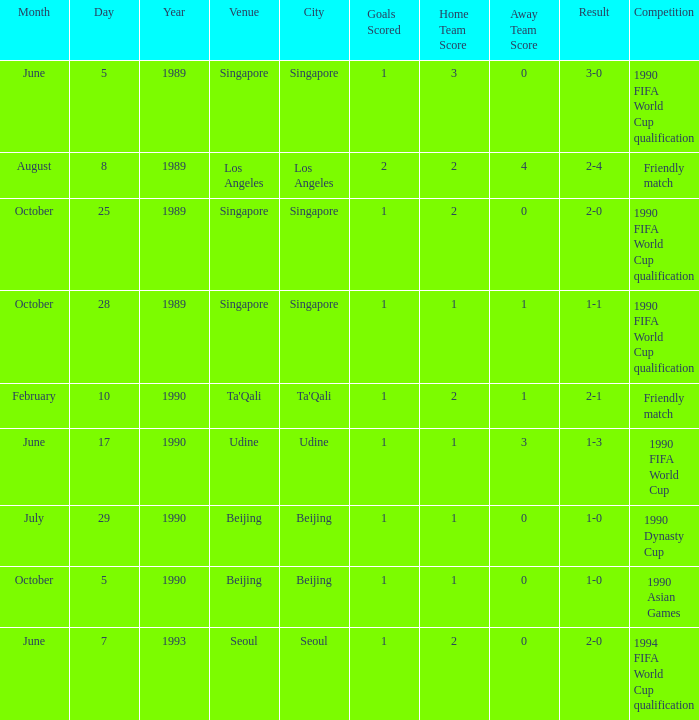In the match that had a 3-0 outcome, what was the score? 1 goal. 